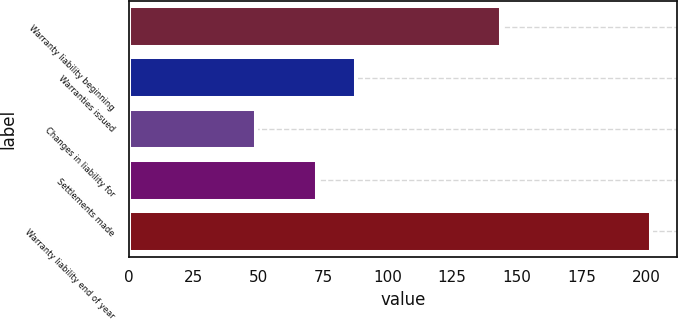Convert chart to OTSL. <chart><loc_0><loc_0><loc_500><loc_500><bar_chart><fcel>Warranty liability beginning<fcel>Warranties issued<fcel>Changes in liability for<fcel>Settlements made<fcel>Warranty liability end of year<nl><fcel>143.7<fcel>87.87<fcel>49.3<fcel>72.6<fcel>202<nl></chart> 